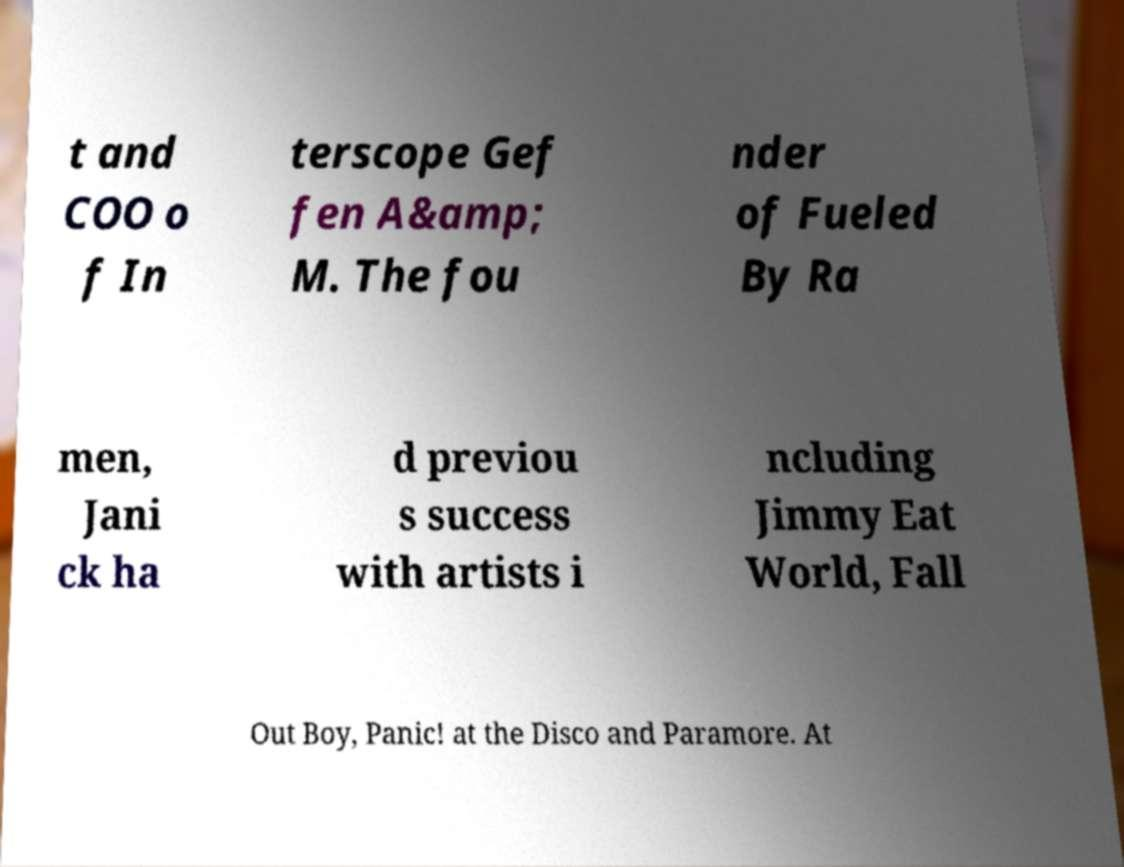For documentation purposes, I need the text within this image transcribed. Could you provide that? t and COO o f In terscope Gef fen A&amp; M. The fou nder of Fueled By Ra men, Jani ck ha d previou s success with artists i ncluding Jimmy Eat World, Fall Out Boy, Panic! at the Disco and Paramore. At 